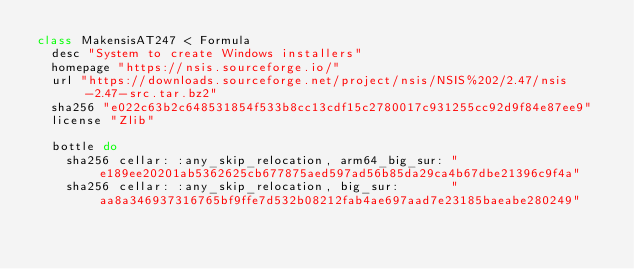Convert code to text. <code><loc_0><loc_0><loc_500><loc_500><_Ruby_>class MakensisAT247 < Formula
  desc "System to create Windows installers"
  homepage "https://nsis.sourceforge.io/"
  url "https://downloads.sourceforge.net/project/nsis/NSIS%202/2.47/nsis-2.47-src.tar.bz2"
  sha256 "e022c63b2c648531854f533b8cc13cdf15c2780017c931255cc92d9f84e87ee9"
  license "Zlib"

  bottle do
    sha256 cellar: :any_skip_relocation, arm64_big_sur: "e189ee20201ab5362625cb677875aed597ad56b85da29ca4b67dbe21396c9f4a"
    sha256 cellar: :any_skip_relocation, big_sur:       "aa8a346937316765bf9ffe7d532b08212fab4ae697aad7e23185baeabe280249"</code> 